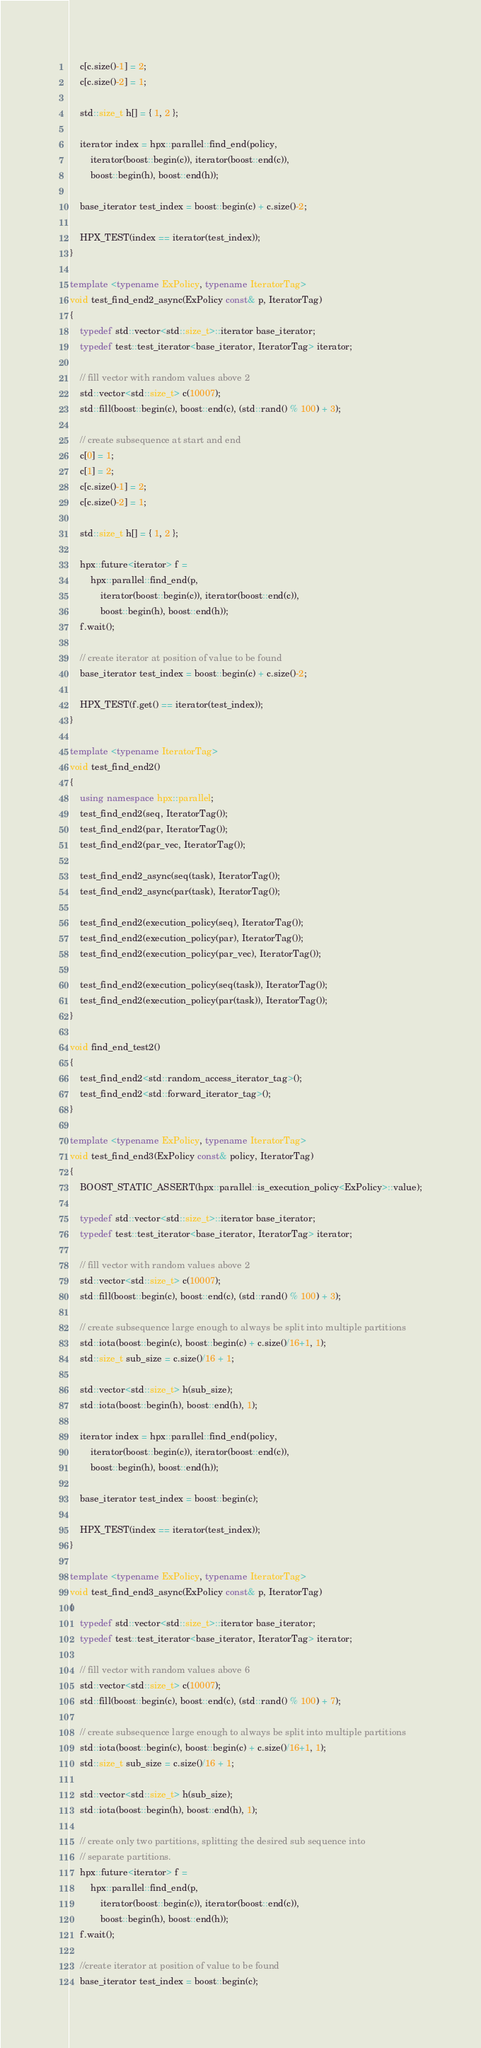<code> <loc_0><loc_0><loc_500><loc_500><_C++_>    c[c.size()-1] = 2;
    c[c.size()-2] = 1;

    std::size_t h[] = { 1, 2 };

    iterator index = hpx::parallel::find_end(policy,
        iterator(boost::begin(c)), iterator(boost::end(c)),
        boost::begin(h), boost::end(h));

    base_iterator test_index = boost::begin(c) + c.size()-2;

    HPX_TEST(index == iterator(test_index));
}

template <typename ExPolicy, typename IteratorTag>
void test_find_end2_async(ExPolicy const& p, IteratorTag)
{
    typedef std::vector<std::size_t>::iterator base_iterator;
    typedef test::test_iterator<base_iterator, IteratorTag> iterator;

    // fill vector with random values above 2
    std::vector<std::size_t> c(10007);
    std::fill(boost::begin(c), boost::end(c), (std::rand() % 100) + 3);

    // create subsequence at start and end
    c[0] = 1;
    c[1] = 2;
    c[c.size()-1] = 2;
    c[c.size()-2] = 1;

    std::size_t h[] = { 1, 2 };

    hpx::future<iterator> f =
        hpx::parallel::find_end(p,
            iterator(boost::begin(c)), iterator(boost::end(c)),
            boost::begin(h), boost::end(h));
    f.wait();

    // create iterator at position of value to be found
    base_iterator test_index = boost::begin(c) + c.size()-2;

    HPX_TEST(f.get() == iterator(test_index));
}

template <typename IteratorTag>
void test_find_end2()
{
    using namespace hpx::parallel;
    test_find_end2(seq, IteratorTag());
    test_find_end2(par, IteratorTag());
    test_find_end2(par_vec, IteratorTag());

    test_find_end2_async(seq(task), IteratorTag());
    test_find_end2_async(par(task), IteratorTag());

    test_find_end2(execution_policy(seq), IteratorTag());
    test_find_end2(execution_policy(par), IteratorTag());
    test_find_end2(execution_policy(par_vec), IteratorTag());

    test_find_end2(execution_policy(seq(task)), IteratorTag());
    test_find_end2(execution_policy(par(task)), IteratorTag());
}

void find_end_test2()
{
    test_find_end2<std::random_access_iterator_tag>();
    test_find_end2<std::forward_iterator_tag>();
}

template <typename ExPolicy, typename IteratorTag>
void test_find_end3(ExPolicy const& policy, IteratorTag)
{
    BOOST_STATIC_ASSERT(hpx::parallel::is_execution_policy<ExPolicy>::value);

    typedef std::vector<std::size_t>::iterator base_iterator;
    typedef test::test_iterator<base_iterator, IteratorTag> iterator;

    // fill vector with random values above 2
    std::vector<std::size_t> c(10007);
    std::fill(boost::begin(c), boost::end(c), (std::rand() % 100) + 3);

    // create subsequence large enough to always be split into multiple partitions
    std::iota(boost::begin(c), boost::begin(c) + c.size()/16+1, 1);
    std::size_t sub_size = c.size()/16 + 1;

    std::vector<std::size_t> h(sub_size);
    std::iota(boost::begin(h), boost::end(h), 1);

    iterator index = hpx::parallel::find_end(policy,
        iterator(boost::begin(c)), iterator(boost::end(c)),
        boost::begin(h), boost::end(h));

    base_iterator test_index = boost::begin(c);

    HPX_TEST(index == iterator(test_index));
}

template <typename ExPolicy, typename IteratorTag>
void test_find_end3_async(ExPolicy const& p, IteratorTag)
{
    typedef std::vector<std::size_t>::iterator base_iterator;
    typedef test::test_iterator<base_iterator, IteratorTag> iterator;

    // fill vector with random values above 6
    std::vector<std::size_t> c(10007);
    std::fill(boost::begin(c), boost::end(c), (std::rand() % 100) + 7);

    // create subsequence large enough to always be split into multiple partitions
    std::iota(boost::begin(c), boost::begin(c) + c.size()/16+1, 1);
    std::size_t sub_size = c.size()/16 + 1;

    std::vector<std::size_t> h(sub_size);
    std::iota(boost::begin(h), boost::end(h), 1);

    // create only two partitions, splitting the desired sub sequence into
    // separate partitions.
    hpx::future<iterator> f =
        hpx::parallel::find_end(p,
            iterator(boost::begin(c)), iterator(boost::end(c)),
            boost::begin(h), boost::end(h));
    f.wait();

    //create iterator at position of value to be found
    base_iterator test_index = boost::begin(c);
</code> 